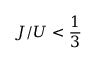Convert formula to latex. <formula><loc_0><loc_0><loc_500><loc_500>J / U < \frac { 1 } { 3 }</formula> 